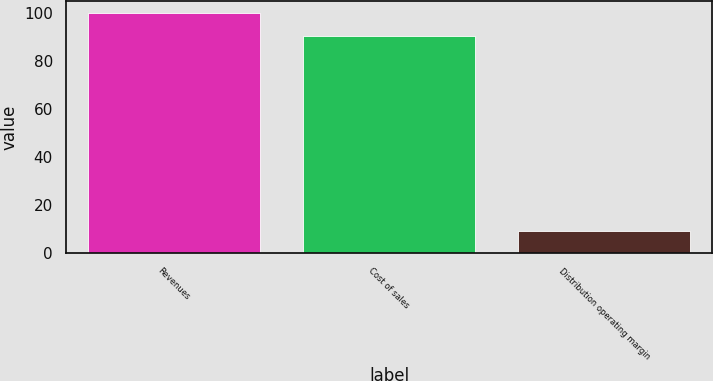Convert chart to OTSL. <chart><loc_0><loc_0><loc_500><loc_500><bar_chart><fcel>Revenues<fcel>Cost of sales<fcel>Distribution operating margin<nl><fcel>100<fcel>90.8<fcel>9.2<nl></chart> 